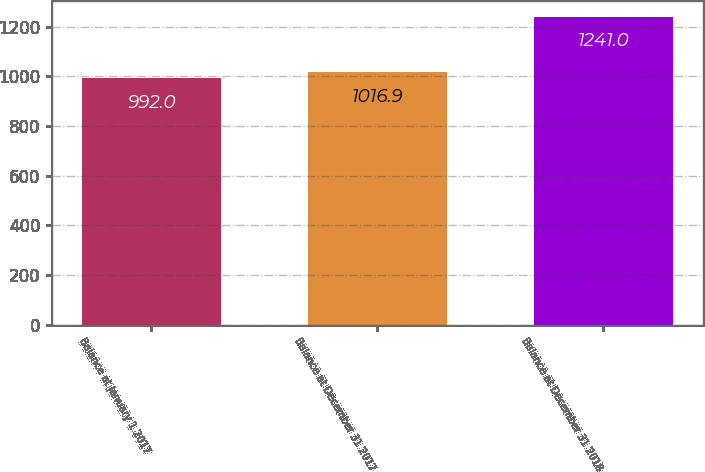Convert chart. <chart><loc_0><loc_0><loc_500><loc_500><bar_chart><fcel>Balance at January 1 2017<fcel>Balance at December 31 2017<fcel>Balance at December 31 2018<nl><fcel>992<fcel>1016.9<fcel>1241<nl></chart> 